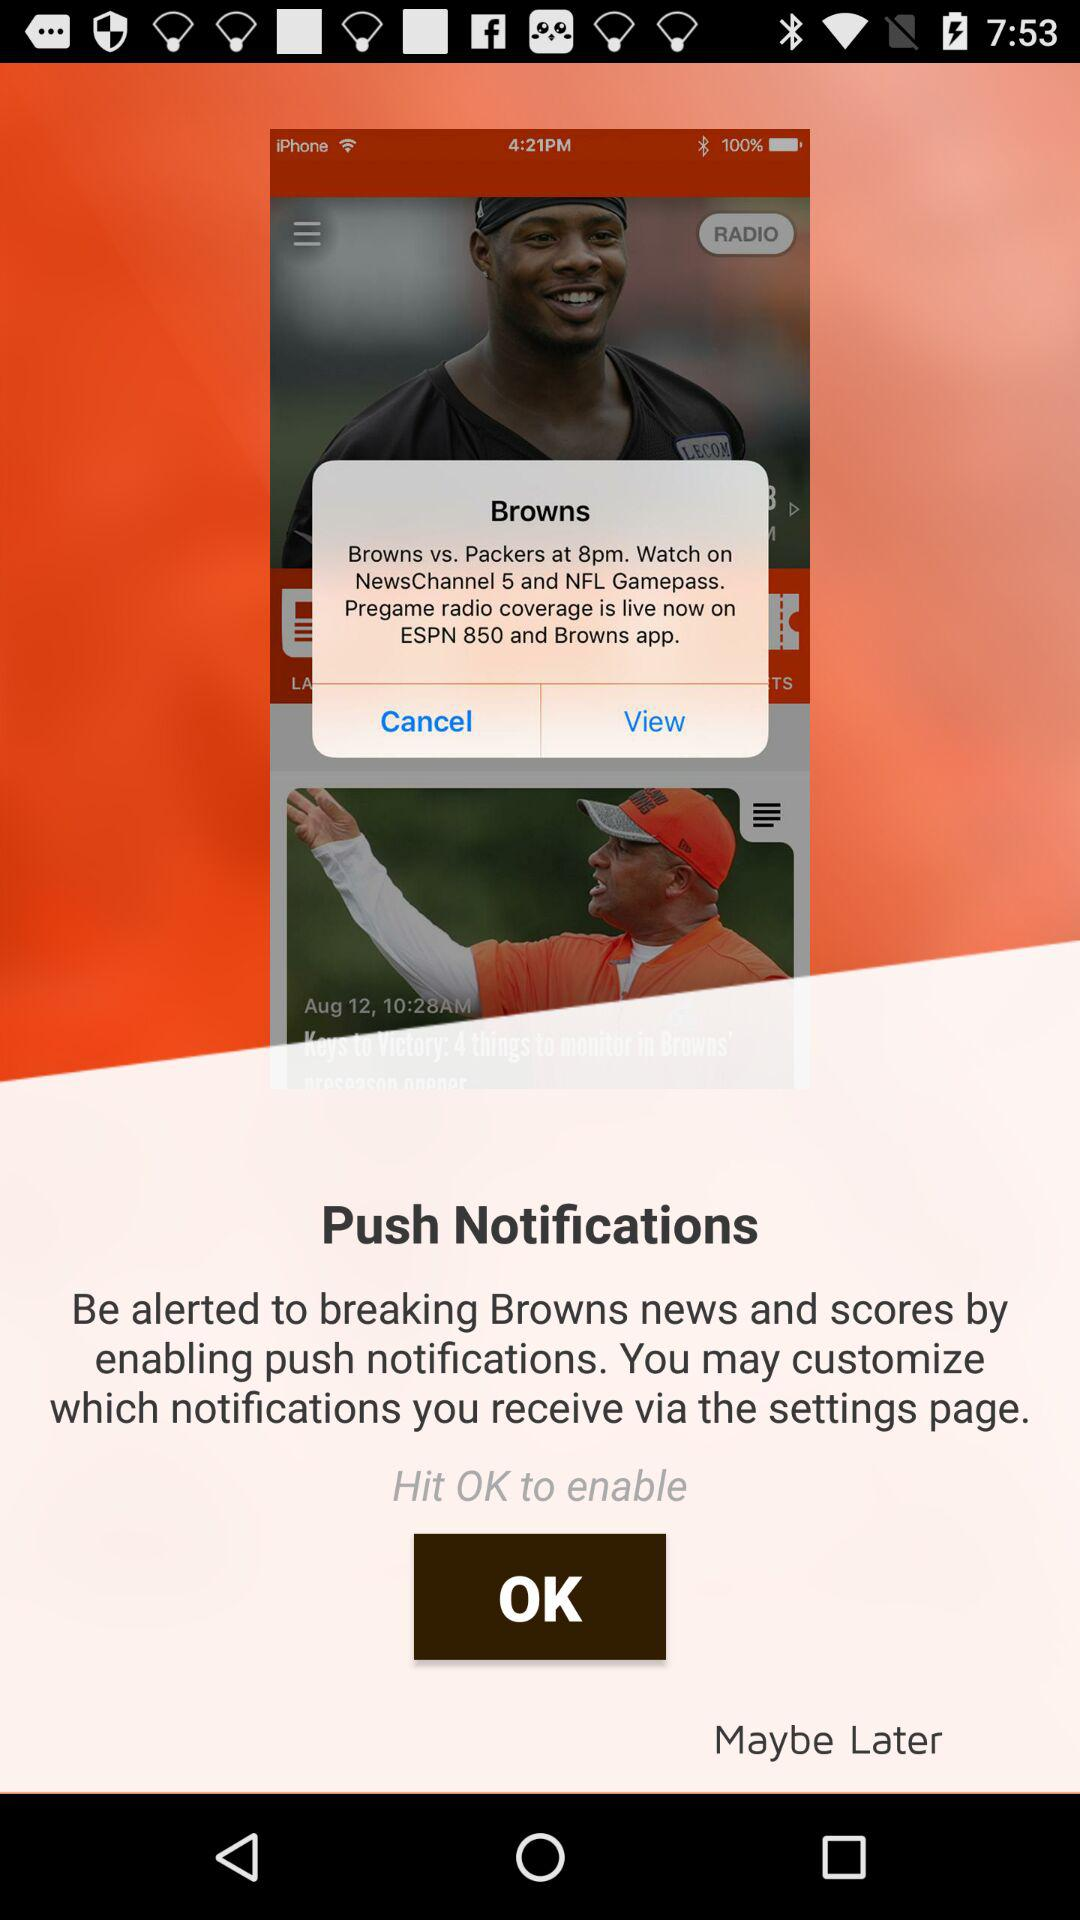What are the timings of the Browns vs. Packers match? The time of the match is 8 pm. 